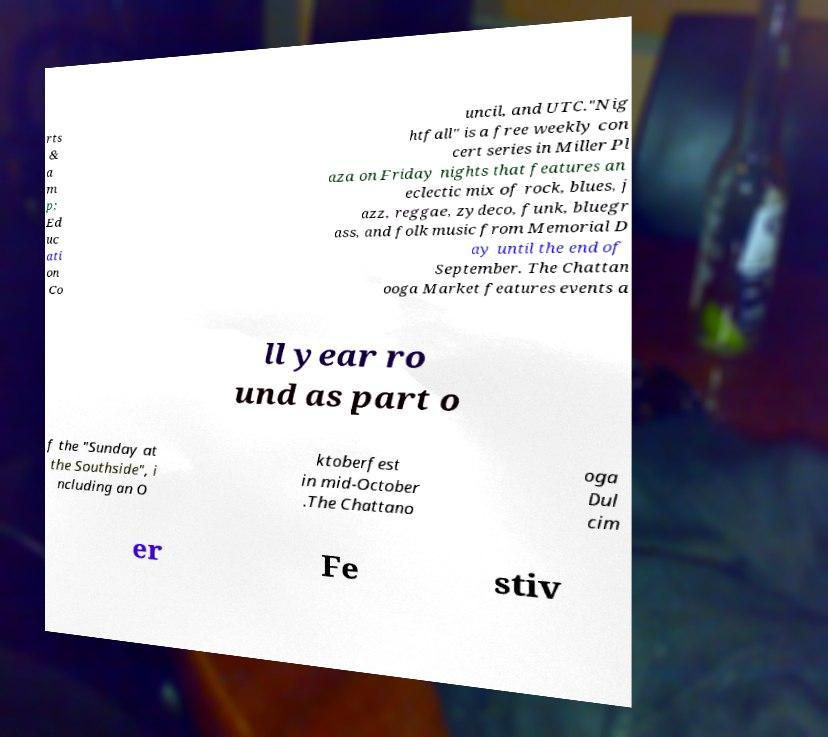Can you accurately transcribe the text from the provided image for me? rts & a m p; Ed uc ati on Co uncil, and UTC."Nig htfall" is a free weekly con cert series in Miller Pl aza on Friday nights that features an eclectic mix of rock, blues, j azz, reggae, zydeco, funk, bluegr ass, and folk music from Memorial D ay until the end of September. The Chattan ooga Market features events a ll year ro und as part o f the "Sunday at the Southside", i ncluding an O ktoberfest in mid-October .The Chattano oga Dul cim er Fe stiv 